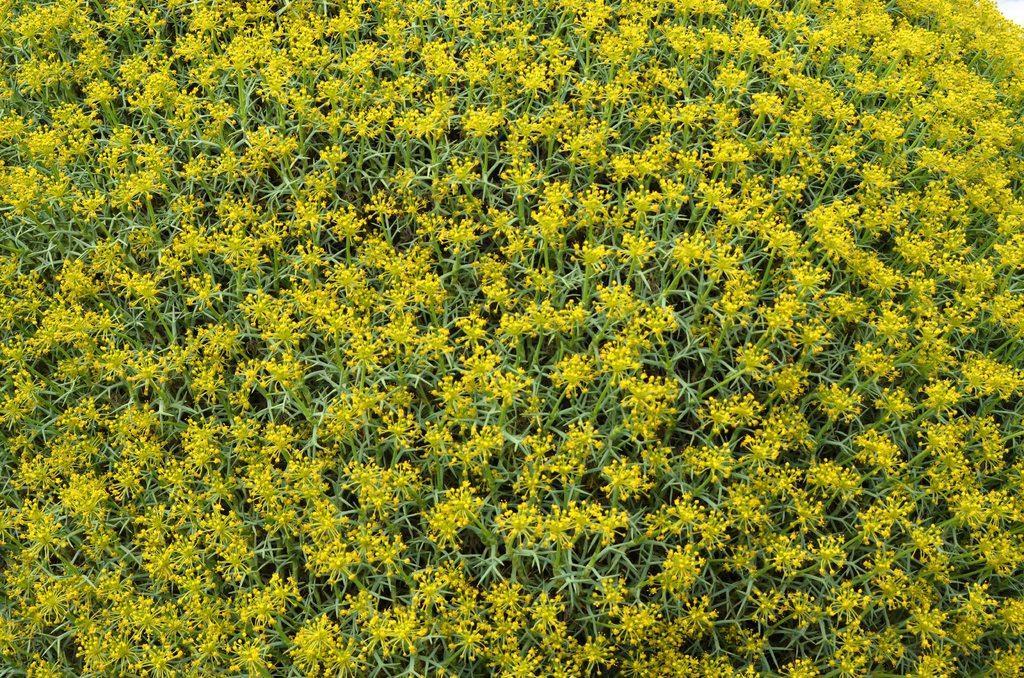How would you summarize this image in a sentence or two? In this image we can see few yellow color flowers to plants. 